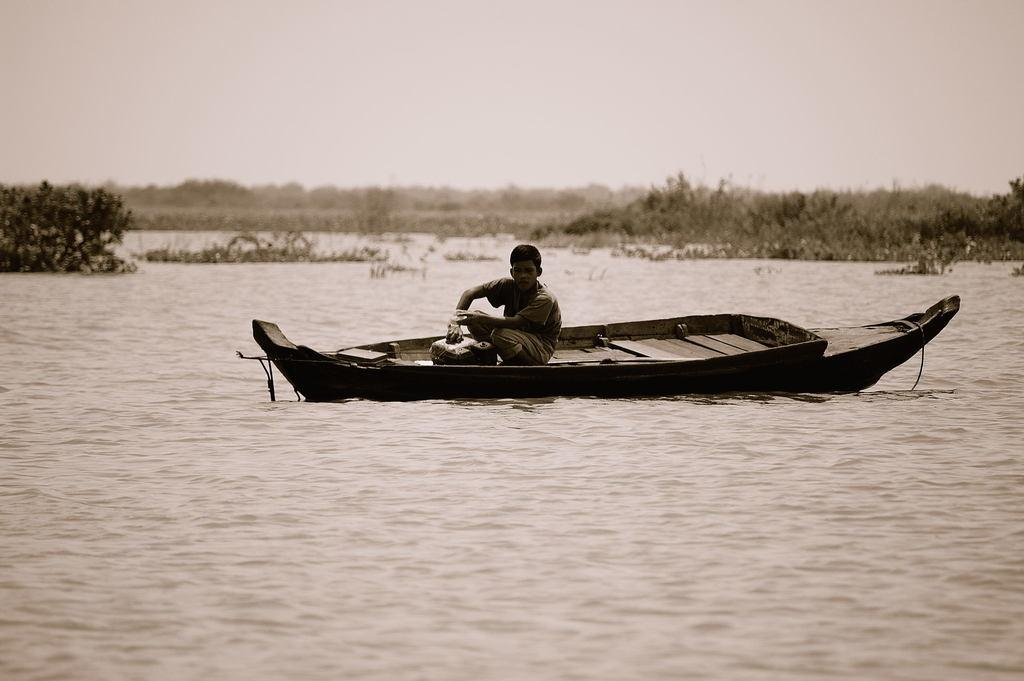What is the main subject of the image? The main subject of the image is a boat on a water surface. Who or what is on the boat? A boy is sitting on the boat. What can be seen in the background of the image? There are plants and the sky visible in the background of the image. What type of bone is the boy holding in the image? There is no bone present in the image; the boy is sitting on the boat without any visible objects in his hands. 